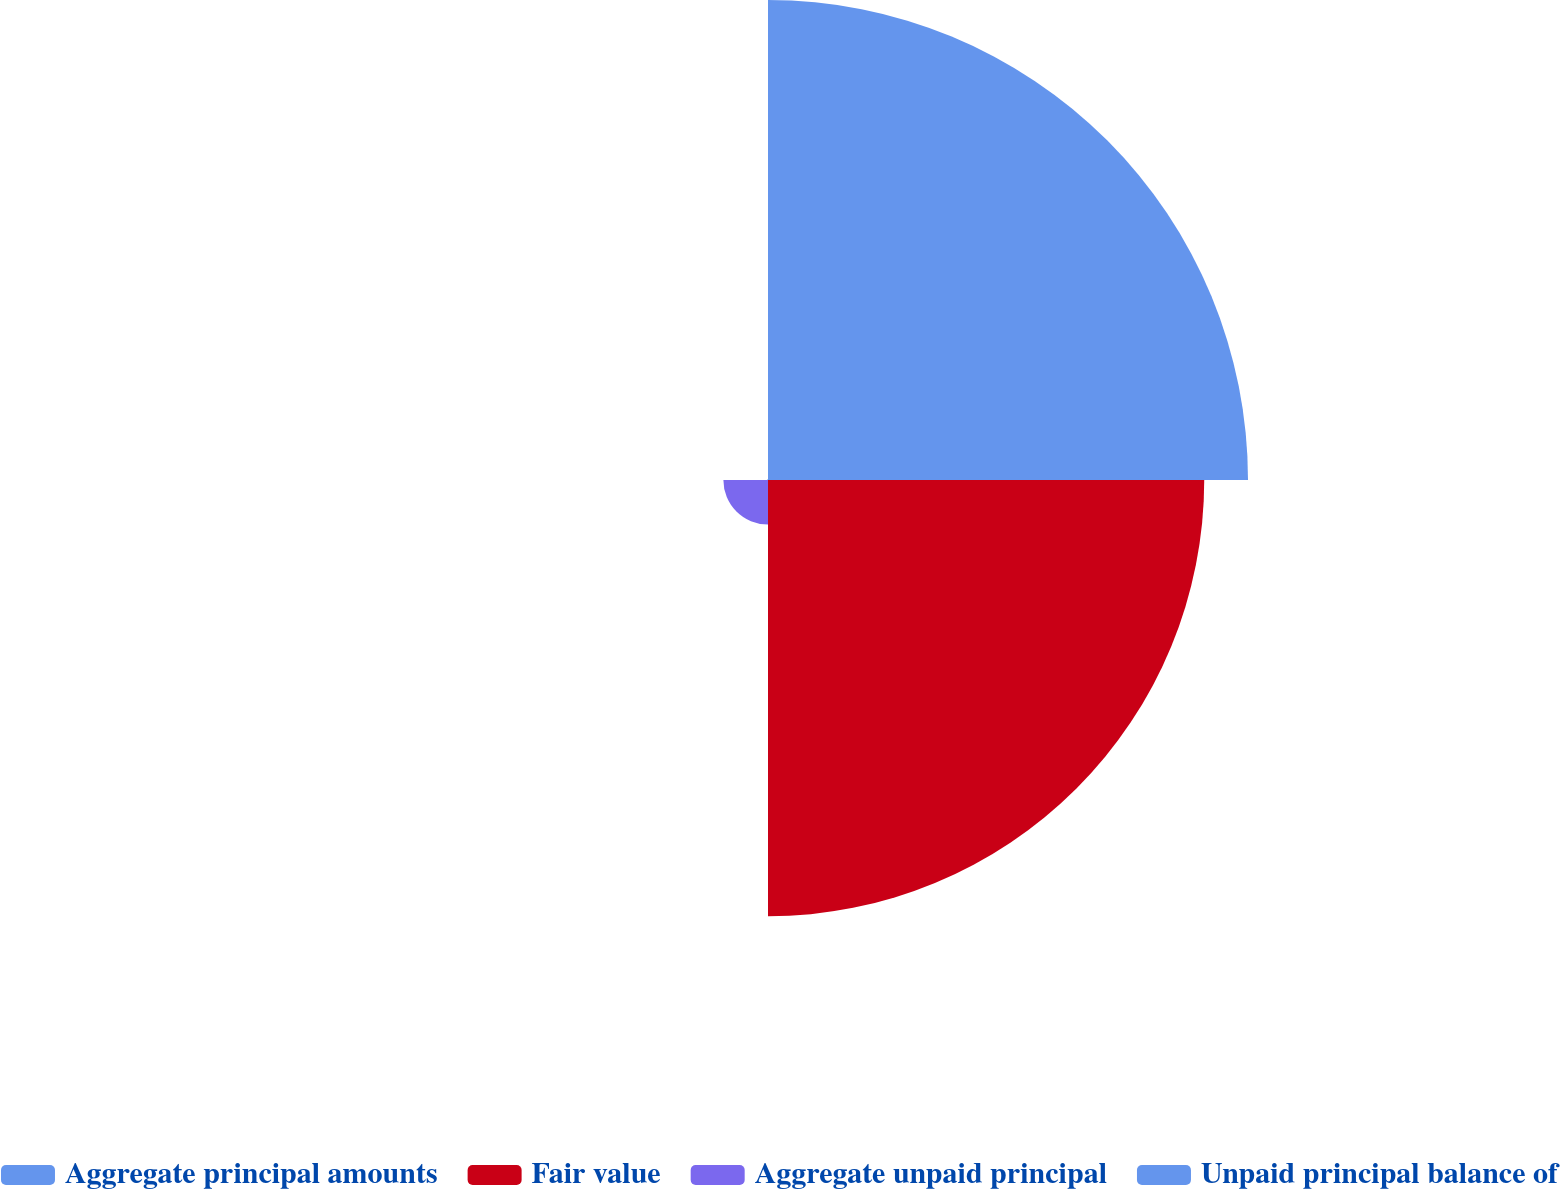<chart> <loc_0><loc_0><loc_500><loc_500><pie_chart><fcel>Aggregate principal amounts<fcel>Fair value<fcel>Aggregate unpaid principal<fcel>Unpaid principal balance of<nl><fcel>49.91%<fcel>45.36%<fcel>4.64%<fcel>0.09%<nl></chart> 